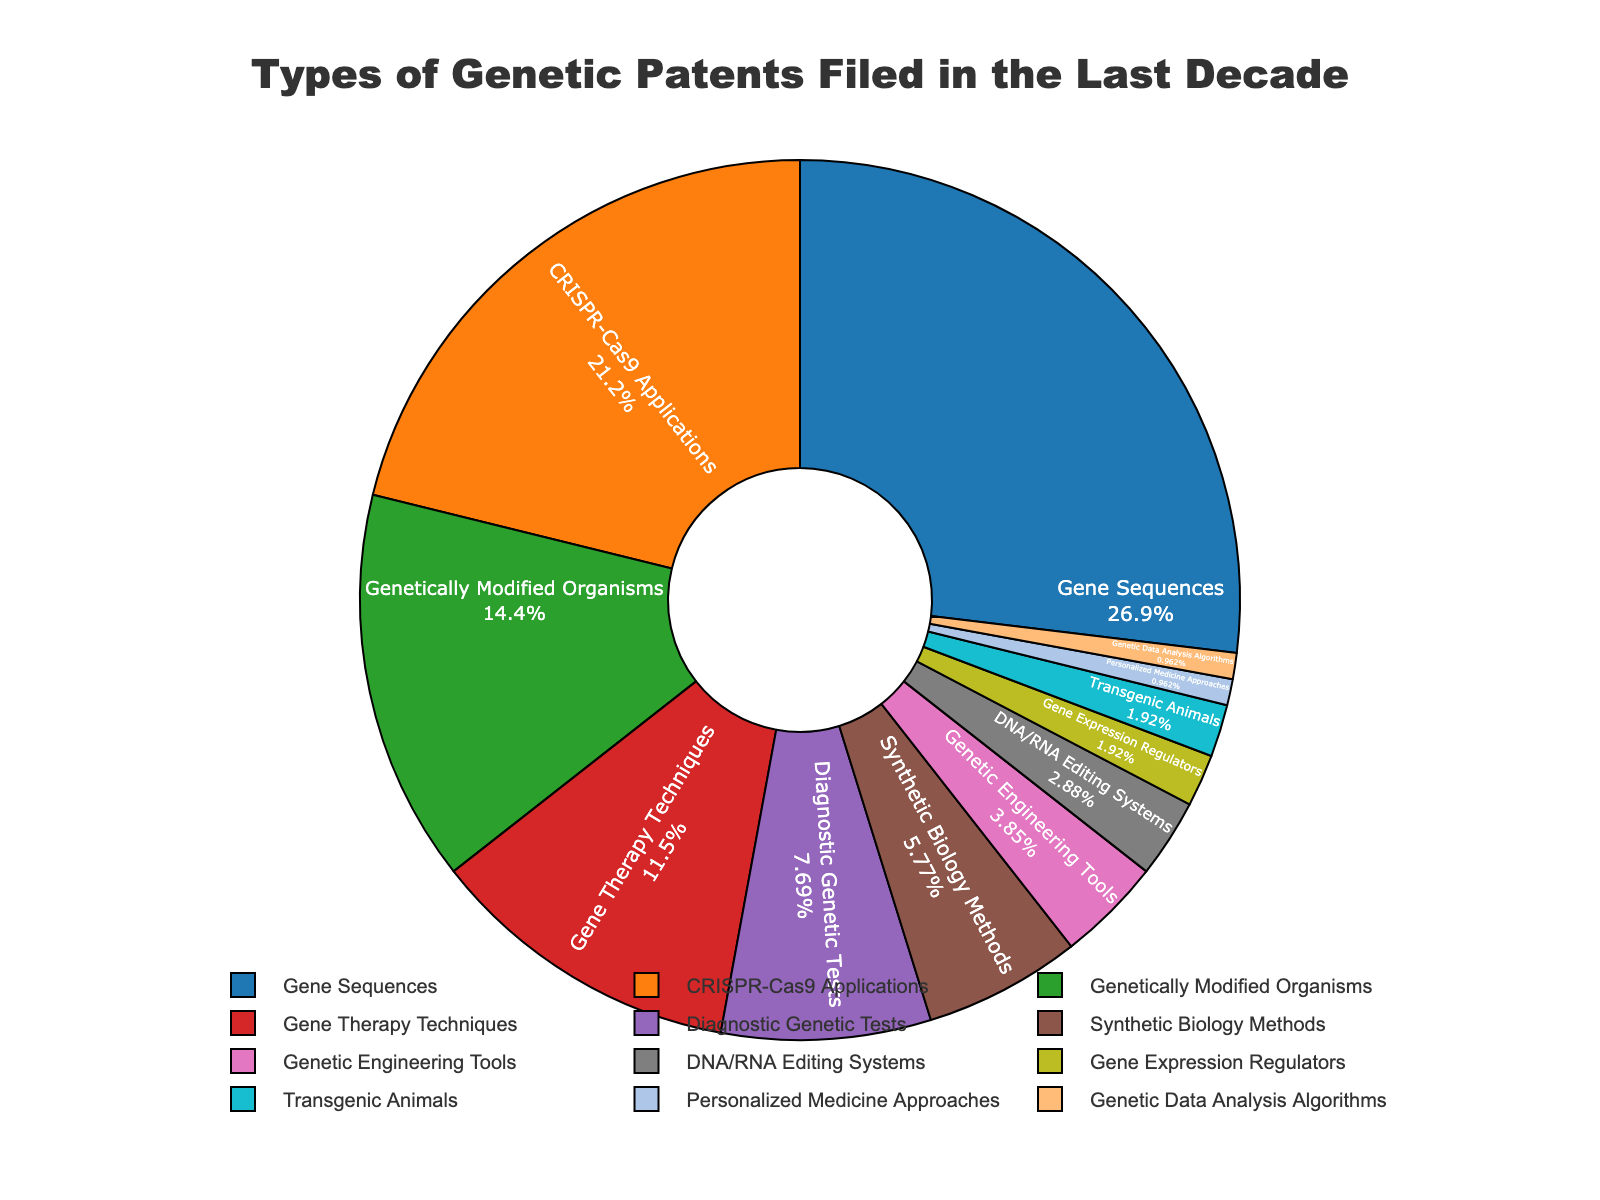Which category has the highest percentage of genetic patents? The figure shows different categories with their respective percentages. The highest percentage is represented by the largest segment of the pie chart.
Answer: Gene Sequences What is the combined percentage of CRISPR-Cas9 Applications and Genetically Modified Organisms? Add the percentages of CRISPR-Cas9 Applications (22%) and Genetically Modified Organisms (15%). 22% + 15% = 37%
Answer: 37% Is the percentage of Genetic Therapy Techniques greater than or equal to 10%? The figure shows the percentage for Gene Therapy Techniques as a segment of the pie chart. It's 12%, which is greater than 10%.
Answer: Yes Which category appears smaller in percentage: Transgenic Animals or Genetic Data Analysis Algorithms? The figure shows the sizes of the pie segments. Both Transgenic Animals and Genetic Data Analysis Algorithms have the same smaller segments, represented by 2% and 1%, respectively.
Answer: Genetic Data Analysis Algorithms What is the difference in percentage between Gene Sequences and Diagnostic Genetic Tests? Subtract the percentage of Diagnostic Genetic Tests (8%) from Gene Sequences (28%). 28% - 8% = 20%
Answer: 20% Which categories combined account for more than 50% of the genetic patents? Add the percentages of the largest segments until the sum exceeds 50%. Gene Sequences (28%) + CRISPR-Cas9 Applications (22%) = 50%
Answer: Gene Sequences and CRISPR-Cas9 Applications Are Personalized Medicine Approaches and Genetic Data Analysis Algorithms represented by the same-sized segment in the pie chart? Look at the percentage sizes for Personalized Medicine Approaches and Genetic Data Analysis Algorithms in the chart. Both are 1%.
Answer: Yes 